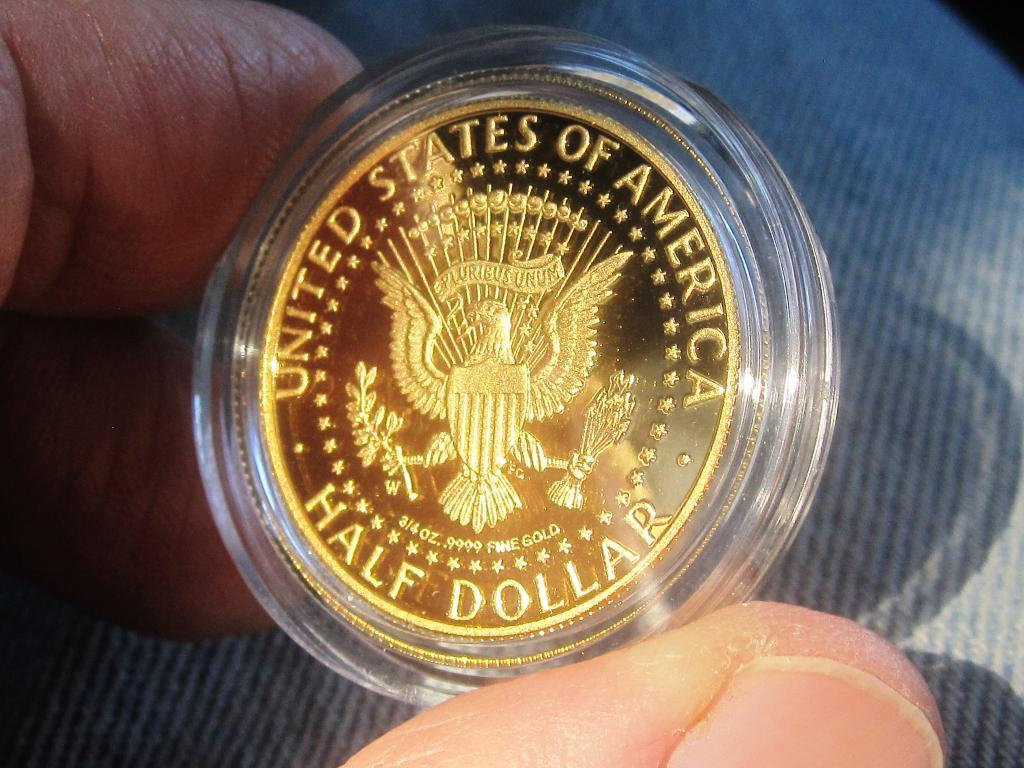<image>
Share a concise interpretation of the image provided. A hand is holding a US half dollar gold coin in its clear casing. 